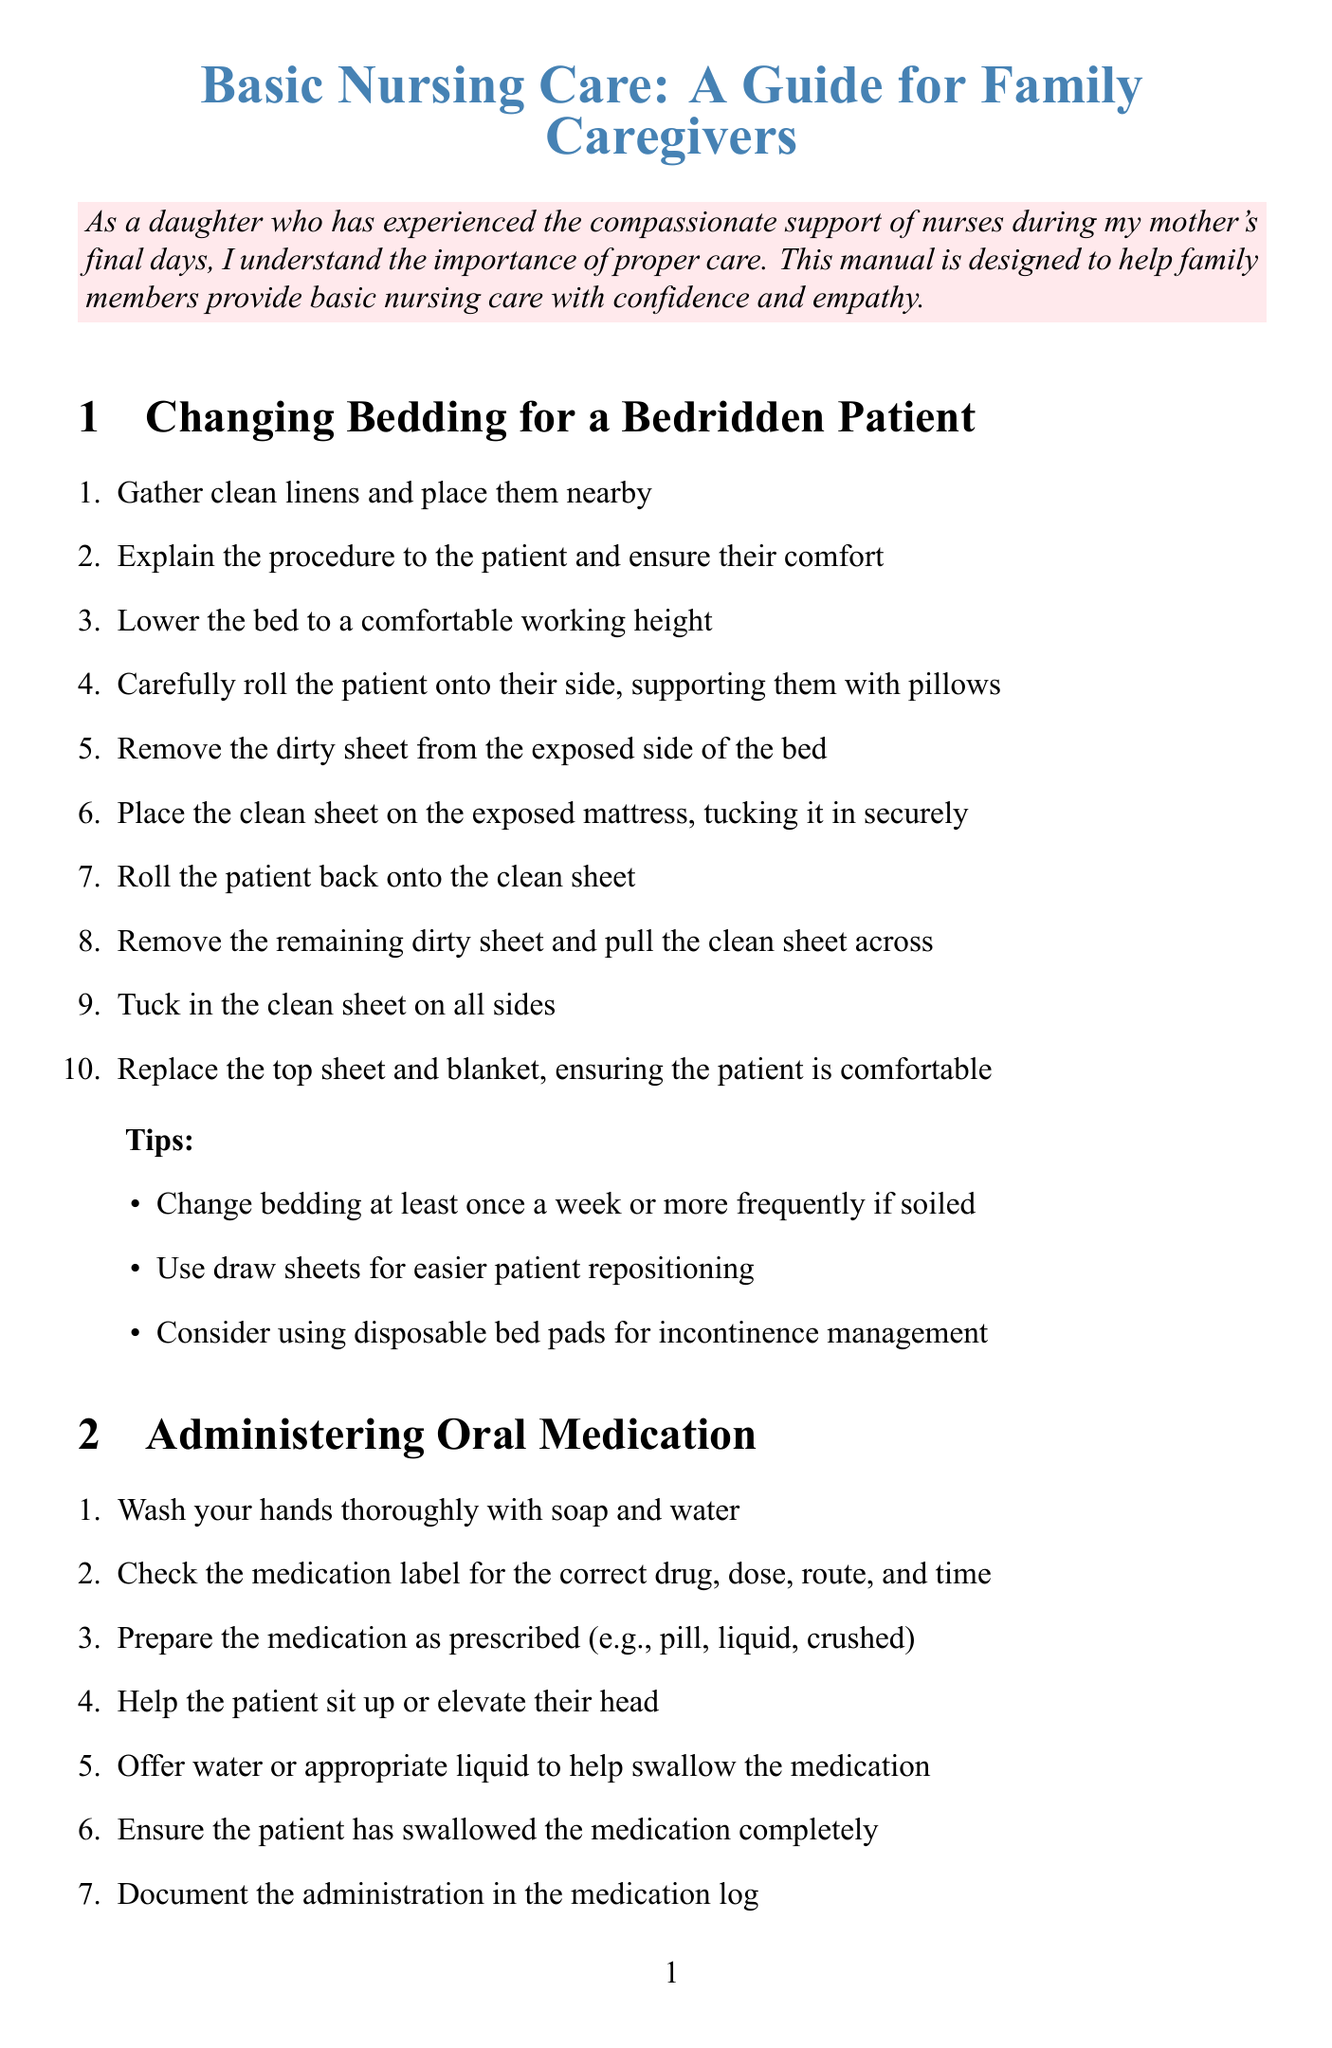What is the title of the manual? The title is mentioned in the document's header as the main topic of the guide.
Answer: Basic Nursing Care: A Guide for Family Caregivers How many steps are there for changing bedding? The document lists the steps for changing bedding in a numbered format, which totals to ten steps.
Answer: 10 What is the first step in administering oral medication? The first step is clearly stated in the procedure list for administering oral medication.
Answer: Wash your hands thoroughly with soap and water What should you use for easier patient repositioning? The tips section includes suggestions for assisting with the changing of bedding.
Answer: Draw sheets How often should vital signs be checked? The document specifies how frequently vital signs should be monitored based on healthcare guidance.
Answer: 2-3 times daily What equipment is needed to monitor vital signs? The manual lists the necessary equipment needed for monitoring in a distinct section.
Answer: Digital thermometer, Blood pressure cuff, Pulse oximeter, Watch with a second hand What is emphasized at the end of the document? The conclusion section emphasizes the importance of compassion and care for the patient's comfort and seeking help when needed.
Answer: Compassion and care Which section provides steps for bathing? The "Assisting with Personal Hygiene" section includes subtopics and steps for bathing.
Answer: Assisting with Personal Hygiene 